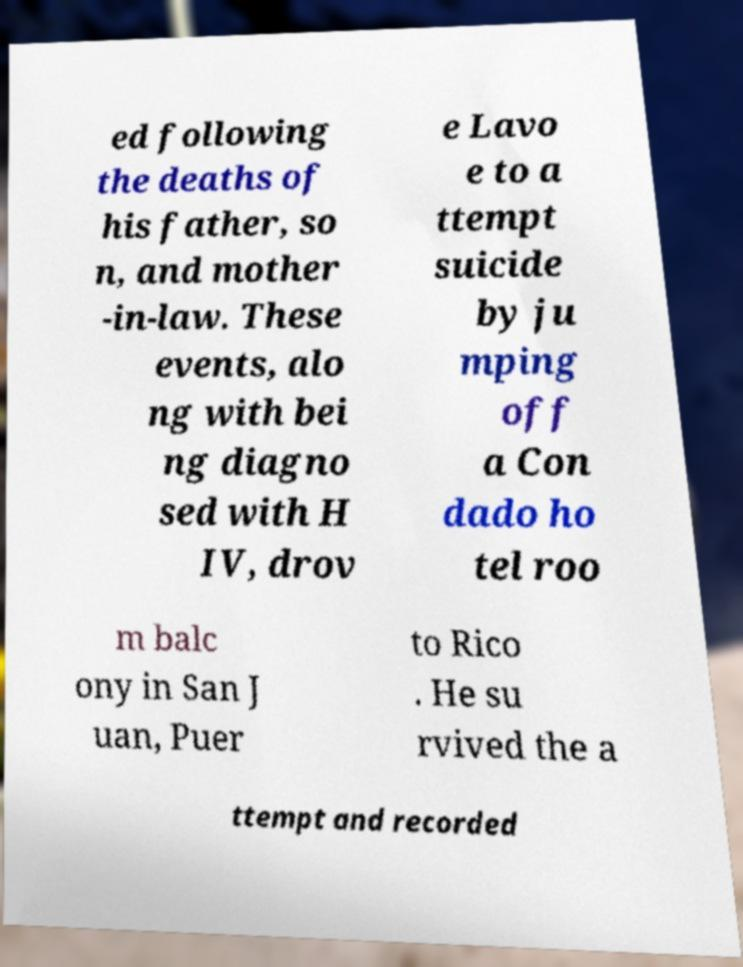I need the written content from this picture converted into text. Can you do that? ed following the deaths of his father, so n, and mother -in-law. These events, alo ng with bei ng diagno sed with H IV, drov e Lavo e to a ttempt suicide by ju mping off a Con dado ho tel roo m balc ony in San J uan, Puer to Rico . He su rvived the a ttempt and recorded 